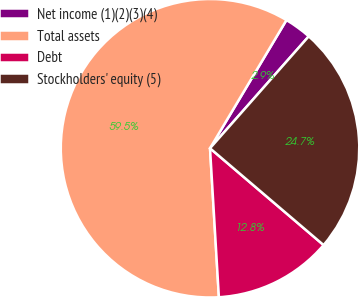Convert chart to OTSL. <chart><loc_0><loc_0><loc_500><loc_500><pie_chart><fcel>Net income (1)(2)(3)(4)<fcel>Total assets<fcel>Debt<fcel>Stockholders' equity (5)<nl><fcel>2.95%<fcel>59.51%<fcel>12.82%<fcel>24.73%<nl></chart> 